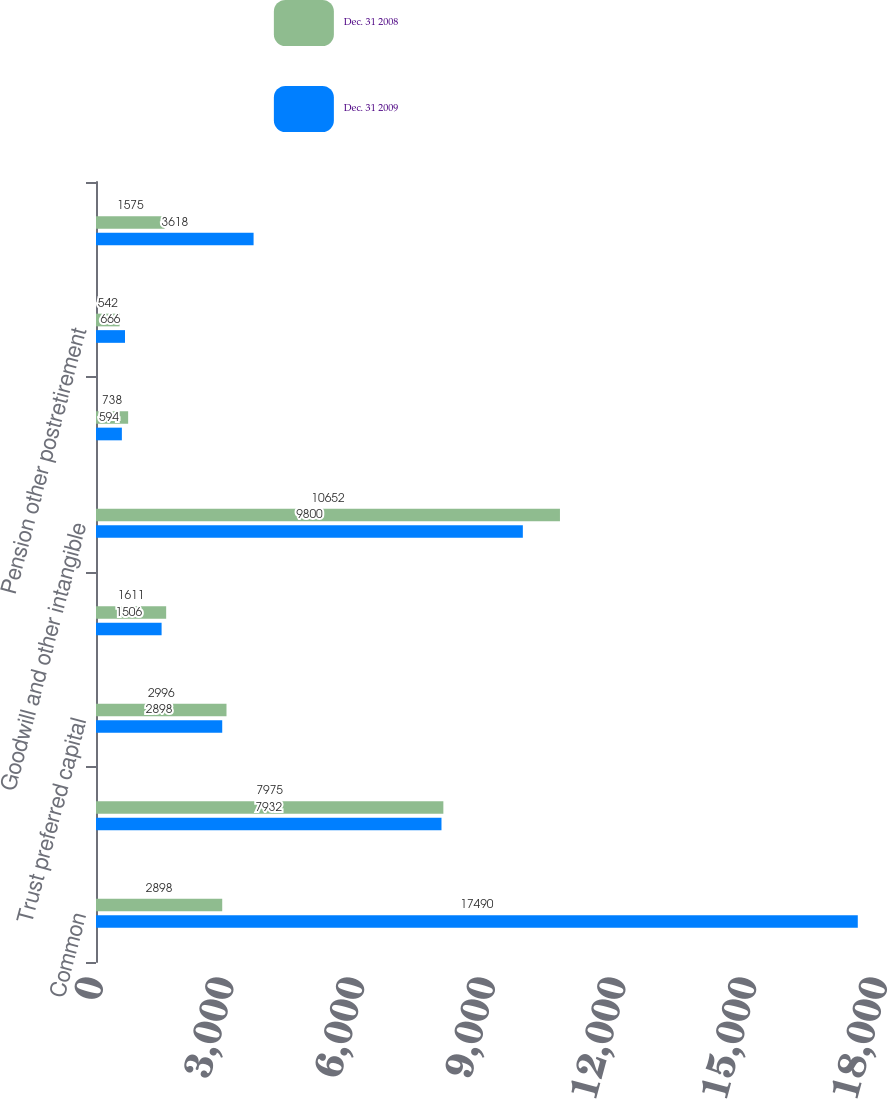Convert chart to OTSL. <chart><loc_0><loc_0><loc_500><loc_500><stacked_bar_chart><ecel><fcel>Common<fcel>Preferred<fcel>Trust preferred capital<fcel>Noncontrolling interests<fcel>Goodwill and other intangible<fcel>Eligible deferred income taxes<fcel>Pension other postretirement<fcel>Net unrealized securities<nl><fcel>Dec. 31 2008<fcel>2898<fcel>7975<fcel>2996<fcel>1611<fcel>10652<fcel>738<fcel>542<fcel>1575<nl><fcel>Dec. 31 2009<fcel>17490<fcel>7932<fcel>2898<fcel>1506<fcel>9800<fcel>594<fcel>666<fcel>3618<nl></chart> 